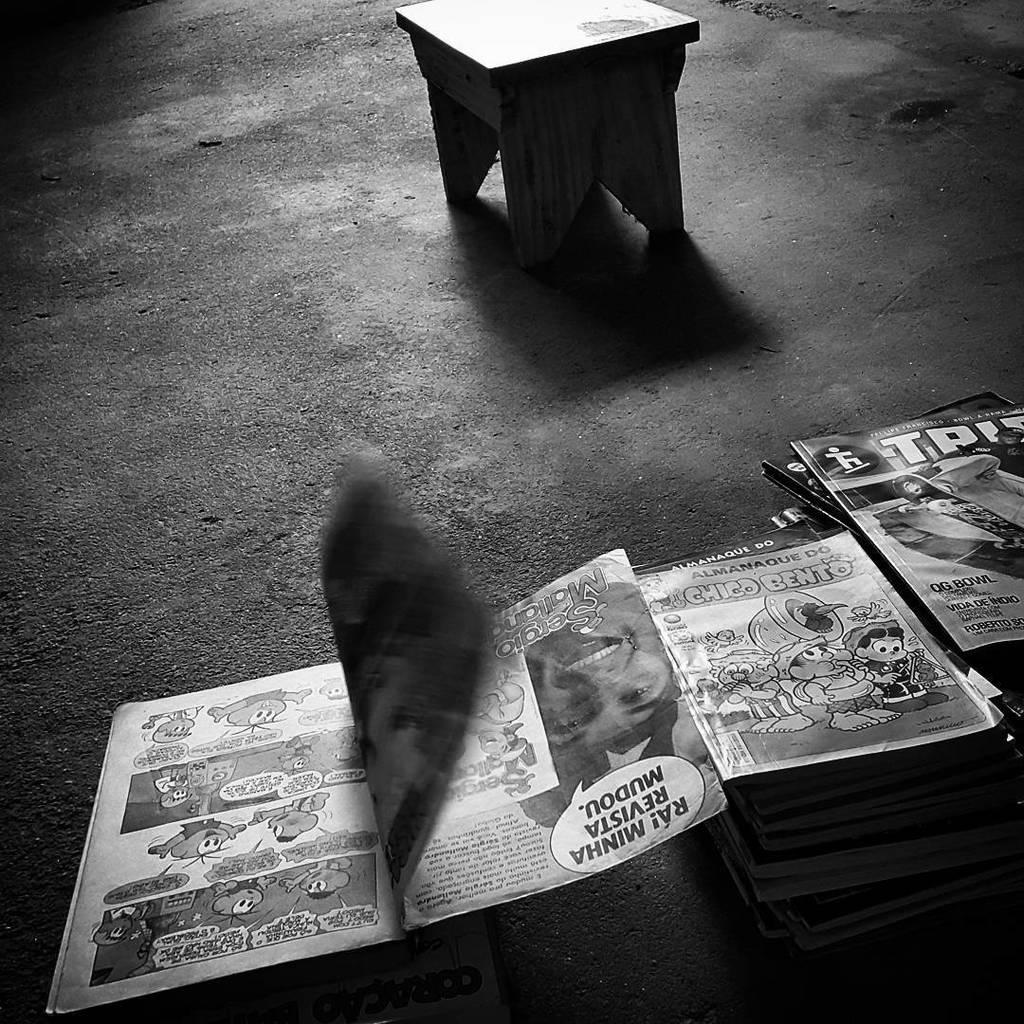What objects are present in the image? There are books and a stool in the image. Where are the books located in the image? The books are on the down side of the image. Where is the stool located in the image? The stool is at the top of the image. What type of operation is being performed on the books in the image? There is no operation being performed on the books in the image; they are simply present on the down side of the image. 